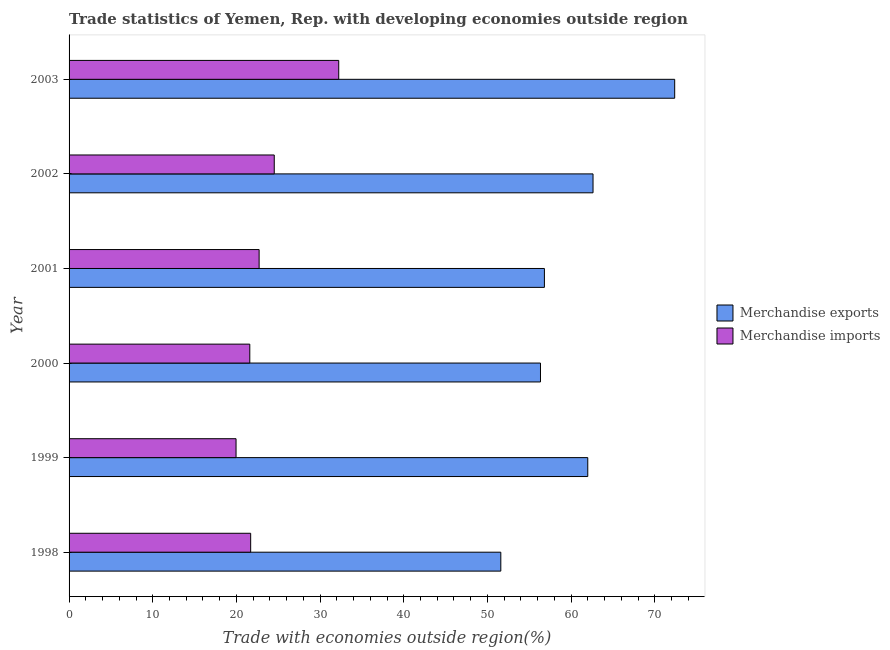How many groups of bars are there?
Provide a short and direct response. 6. How many bars are there on the 3rd tick from the top?
Your response must be concise. 2. How many bars are there on the 2nd tick from the bottom?
Provide a short and direct response. 2. What is the label of the 1st group of bars from the top?
Your answer should be very brief. 2003. What is the merchandise exports in 1999?
Your answer should be very brief. 61.99. Across all years, what is the maximum merchandise imports?
Your response must be concise. 32.23. Across all years, what is the minimum merchandise exports?
Offer a terse response. 51.6. What is the total merchandise imports in the graph?
Make the answer very short. 142.72. What is the difference between the merchandise imports in 2002 and that in 2003?
Provide a succinct answer. -7.71. What is the difference between the merchandise exports in 1998 and the merchandise imports in 2000?
Keep it short and to the point. 30. What is the average merchandise exports per year?
Your response must be concise. 60.29. In the year 1998, what is the difference between the merchandise exports and merchandise imports?
Ensure brevity in your answer.  29.9. What is the ratio of the merchandise imports in 1999 to that in 2000?
Keep it short and to the point. 0.92. Is the difference between the merchandise imports in 1999 and 2002 greater than the difference between the merchandise exports in 1999 and 2002?
Your answer should be compact. No. What is the difference between the highest and the second highest merchandise imports?
Offer a terse response. 7.71. What is the difference between the highest and the lowest merchandise exports?
Make the answer very short. 20.78. What does the 2nd bar from the top in 2002 represents?
Offer a very short reply. Merchandise exports. What does the 2nd bar from the bottom in 1998 represents?
Provide a succinct answer. Merchandise imports. How many years are there in the graph?
Make the answer very short. 6. What is the difference between two consecutive major ticks on the X-axis?
Provide a short and direct response. 10. Does the graph contain grids?
Keep it short and to the point. No. How many legend labels are there?
Make the answer very short. 2. What is the title of the graph?
Make the answer very short. Trade statistics of Yemen, Rep. with developing economies outside region. What is the label or title of the X-axis?
Your answer should be compact. Trade with economies outside region(%). What is the label or title of the Y-axis?
Provide a succinct answer. Year. What is the Trade with economies outside region(%) of Merchandise exports in 1998?
Offer a terse response. 51.6. What is the Trade with economies outside region(%) in Merchandise imports in 1998?
Offer a terse response. 21.7. What is the Trade with economies outside region(%) in Merchandise exports in 1999?
Your answer should be very brief. 61.99. What is the Trade with economies outside region(%) in Merchandise imports in 1999?
Keep it short and to the point. 19.96. What is the Trade with economies outside region(%) of Merchandise exports in 2000?
Give a very brief answer. 56.34. What is the Trade with economies outside region(%) of Merchandise imports in 2000?
Give a very brief answer. 21.6. What is the Trade with economies outside region(%) of Merchandise exports in 2001?
Provide a short and direct response. 56.81. What is the Trade with economies outside region(%) in Merchandise imports in 2001?
Your answer should be compact. 22.71. What is the Trade with economies outside region(%) in Merchandise exports in 2002?
Keep it short and to the point. 62.62. What is the Trade with economies outside region(%) in Merchandise imports in 2002?
Your answer should be compact. 24.52. What is the Trade with economies outside region(%) in Merchandise exports in 2003?
Your answer should be very brief. 72.38. What is the Trade with economies outside region(%) in Merchandise imports in 2003?
Offer a terse response. 32.23. Across all years, what is the maximum Trade with economies outside region(%) in Merchandise exports?
Provide a succinct answer. 72.38. Across all years, what is the maximum Trade with economies outside region(%) of Merchandise imports?
Your answer should be compact. 32.23. Across all years, what is the minimum Trade with economies outside region(%) of Merchandise exports?
Provide a succinct answer. 51.6. Across all years, what is the minimum Trade with economies outside region(%) of Merchandise imports?
Provide a short and direct response. 19.96. What is the total Trade with economies outside region(%) of Merchandise exports in the graph?
Ensure brevity in your answer.  361.74. What is the total Trade with economies outside region(%) of Merchandise imports in the graph?
Provide a short and direct response. 142.72. What is the difference between the Trade with economies outside region(%) in Merchandise exports in 1998 and that in 1999?
Make the answer very short. -10.39. What is the difference between the Trade with economies outside region(%) in Merchandise imports in 1998 and that in 1999?
Make the answer very short. 1.75. What is the difference between the Trade with economies outside region(%) in Merchandise exports in 1998 and that in 2000?
Offer a very short reply. -4.74. What is the difference between the Trade with economies outside region(%) in Merchandise imports in 1998 and that in 2000?
Offer a terse response. 0.1. What is the difference between the Trade with economies outside region(%) of Merchandise exports in 1998 and that in 2001?
Give a very brief answer. -5.21. What is the difference between the Trade with economies outside region(%) of Merchandise imports in 1998 and that in 2001?
Ensure brevity in your answer.  -1.01. What is the difference between the Trade with economies outside region(%) of Merchandise exports in 1998 and that in 2002?
Your answer should be compact. -11.02. What is the difference between the Trade with economies outside region(%) of Merchandise imports in 1998 and that in 2002?
Provide a short and direct response. -2.82. What is the difference between the Trade with economies outside region(%) of Merchandise exports in 1998 and that in 2003?
Your answer should be compact. -20.78. What is the difference between the Trade with economies outside region(%) in Merchandise imports in 1998 and that in 2003?
Give a very brief answer. -10.53. What is the difference between the Trade with economies outside region(%) of Merchandise exports in 1999 and that in 2000?
Offer a terse response. 5.65. What is the difference between the Trade with economies outside region(%) in Merchandise imports in 1999 and that in 2000?
Your answer should be very brief. -1.64. What is the difference between the Trade with economies outside region(%) in Merchandise exports in 1999 and that in 2001?
Keep it short and to the point. 5.18. What is the difference between the Trade with economies outside region(%) of Merchandise imports in 1999 and that in 2001?
Your response must be concise. -2.76. What is the difference between the Trade with economies outside region(%) of Merchandise exports in 1999 and that in 2002?
Your response must be concise. -0.63. What is the difference between the Trade with economies outside region(%) of Merchandise imports in 1999 and that in 2002?
Your answer should be very brief. -4.57. What is the difference between the Trade with economies outside region(%) of Merchandise exports in 1999 and that in 2003?
Make the answer very short. -10.39. What is the difference between the Trade with economies outside region(%) in Merchandise imports in 1999 and that in 2003?
Ensure brevity in your answer.  -12.27. What is the difference between the Trade with economies outside region(%) in Merchandise exports in 2000 and that in 2001?
Your response must be concise. -0.47. What is the difference between the Trade with economies outside region(%) of Merchandise imports in 2000 and that in 2001?
Your answer should be very brief. -1.11. What is the difference between the Trade with economies outside region(%) of Merchandise exports in 2000 and that in 2002?
Your answer should be compact. -6.28. What is the difference between the Trade with economies outside region(%) of Merchandise imports in 2000 and that in 2002?
Keep it short and to the point. -2.92. What is the difference between the Trade with economies outside region(%) in Merchandise exports in 2000 and that in 2003?
Provide a succinct answer. -16.04. What is the difference between the Trade with economies outside region(%) of Merchandise imports in 2000 and that in 2003?
Your answer should be compact. -10.63. What is the difference between the Trade with economies outside region(%) in Merchandise exports in 2001 and that in 2002?
Your answer should be very brief. -5.81. What is the difference between the Trade with economies outside region(%) of Merchandise imports in 2001 and that in 2002?
Provide a succinct answer. -1.81. What is the difference between the Trade with economies outside region(%) of Merchandise exports in 2001 and that in 2003?
Provide a short and direct response. -15.57. What is the difference between the Trade with economies outside region(%) of Merchandise imports in 2001 and that in 2003?
Keep it short and to the point. -9.52. What is the difference between the Trade with economies outside region(%) in Merchandise exports in 2002 and that in 2003?
Provide a short and direct response. -9.76. What is the difference between the Trade with economies outside region(%) in Merchandise imports in 2002 and that in 2003?
Provide a succinct answer. -7.71. What is the difference between the Trade with economies outside region(%) of Merchandise exports in 1998 and the Trade with economies outside region(%) of Merchandise imports in 1999?
Ensure brevity in your answer.  31.64. What is the difference between the Trade with economies outside region(%) of Merchandise exports in 1998 and the Trade with economies outside region(%) of Merchandise imports in 2000?
Your answer should be very brief. 30. What is the difference between the Trade with economies outside region(%) in Merchandise exports in 1998 and the Trade with economies outside region(%) in Merchandise imports in 2001?
Make the answer very short. 28.89. What is the difference between the Trade with economies outside region(%) of Merchandise exports in 1998 and the Trade with economies outside region(%) of Merchandise imports in 2002?
Make the answer very short. 27.08. What is the difference between the Trade with economies outside region(%) of Merchandise exports in 1998 and the Trade with economies outside region(%) of Merchandise imports in 2003?
Your answer should be compact. 19.37. What is the difference between the Trade with economies outside region(%) in Merchandise exports in 1999 and the Trade with economies outside region(%) in Merchandise imports in 2000?
Provide a succinct answer. 40.39. What is the difference between the Trade with economies outside region(%) in Merchandise exports in 1999 and the Trade with economies outside region(%) in Merchandise imports in 2001?
Offer a terse response. 39.28. What is the difference between the Trade with economies outside region(%) in Merchandise exports in 1999 and the Trade with economies outside region(%) in Merchandise imports in 2002?
Give a very brief answer. 37.47. What is the difference between the Trade with economies outside region(%) in Merchandise exports in 1999 and the Trade with economies outside region(%) in Merchandise imports in 2003?
Provide a short and direct response. 29.76. What is the difference between the Trade with economies outside region(%) of Merchandise exports in 2000 and the Trade with economies outside region(%) of Merchandise imports in 2001?
Ensure brevity in your answer.  33.63. What is the difference between the Trade with economies outside region(%) of Merchandise exports in 2000 and the Trade with economies outside region(%) of Merchandise imports in 2002?
Provide a short and direct response. 31.82. What is the difference between the Trade with economies outside region(%) in Merchandise exports in 2000 and the Trade with economies outside region(%) in Merchandise imports in 2003?
Provide a succinct answer. 24.11. What is the difference between the Trade with economies outside region(%) of Merchandise exports in 2001 and the Trade with economies outside region(%) of Merchandise imports in 2002?
Give a very brief answer. 32.29. What is the difference between the Trade with economies outside region(%) in Merchandise exports in 2001 and the Trade with economies outside region(%) in Merchandise imports in 2003?
Give a very brief answer. 24.58. What is the difference between the Trade with economies outside region(%) in Merchandise exports in 2002 and the Trade with economies outside region(%) in Merchandise imports in 2003?
Keep it short and to the point. 30.39. What is the average Trade with economies outside region(%) in Merchandise exports per year?
Provide a short and direct response. 60.29. What is the average Trade with economies outside region(%) in Merchandise imports per year?
Your response must be concise. 23.79. In the year 1998, what is the difference between the Trade with economies outside region(%) of Merchandise exports and Trade with economies outside region(%) of Merchandise imports?
Provide a short and direct response. 29.9. In the year 1999, what is the difference between the Trade with economies outside region(%) of Merchandise exports and Trade with economies outside region(%) of Merchandise imports?
Offer a terse response. 42.04. In the year 2000, what is the difference between the Trade with economies outside region(%) in Merchandise exports and Trade with economies outside region(%) in Merchandise imports?
Your answer should be very brief. 34.74. In the year 2001, what is the difference between the Trade with economies outside region(%) of Merchandise exports and Trade with economies outside region(%) of Merchandise imports?
Your response must be concise. 34.1. In the year 2002, what is the difference between the Trade with economies outside region(%) of Merchandise exports and Trade with economies outside region(%) of Merchandise imports?
Offer a very short reply. 38.1. In the year 2003, what is the difference between the Trade with economies outside region(%) of Merchandise exports and Trade with economies outside region(%) of Merchandise imports?
Keep it short and to the point. 40.15. What is the ratio of the Trade with economies outside region(%) of Merchandise exports in 1998 to that in 1999?
Offer a very short reply. 0.83. What is the ratio of the Trade with economies outside region(%) in Merchandise imports in 1998 to that in 1999?
Offer a terse response. 1.09. What is the ratio of the Trade with economies outside region(%) in Merchandise exports in 1998 to that in 2000?
Ensure brevity in your answer.  0.92. What is the ratio of the Trade with economies outside region(%) of Merchandise imports in 1998 to that in 2000?
Offer a terse response. 1. What is the ratio of the Trade with economies outside region(%) in Merchandise exports in 1998 to that in 2001?
Provide a succinct answer. 0.91. What is the ratio of the Trade with economies outside region(%) in Merchandise imports in 1998 to that in 2001?
Provide a short and direct response. 0.96. What is the ratio of the Trade with economies outside region(%) in Merchandise exports in 1998 to that in 2002?
Provide a succinct answer. 0.82. What is the ratio of the Trade with economies outside region(%) in Merchandise imports in 1998 to that in 2002?
Provide a short and direct response. 0.89. What is the ratio of the Trade with economies outside region(%) of Merchandise exports in 1998 to that in 2003?
Provide a succinct answer. 0.71. What is the ratio of the Trade with economies outside region(%) in Merchandise imports in 1998 to that in 2003?
Your answer should be compact. 0.67. What is the ratio of the Trade with economies outside region(%) in Merchandise exports in 1999 to that in 2000?
Your answer should be compact. 1.1. What is the ratio of the Trade with economies outside region(%) in Merchandise imports in 1999 to that in 2000?
Give a very brief answer. 0.92. What is the ratio of the Trade with economies outside region(%) of Merchandise exports in 1999 to that in 2001?
Ensure brevity in your answer.  1.09. What is the ratio of the Trade with economies outside region(%) of Merchandise imports in 1999 to that in 2001?
Give a very brief answer. 0.88. What is the ratio of the Trade with economies outside region(%) in Merchandise imports in 1999 to that in 2002?
Your response must be concise. 0.81. What is the ratio of the Trade with economies outside region(%) in Merchandise exports in 1999 to that in 2003?
Ensure brevity in your answer.  0.86. What is the ratio of the Trade with economies outside region(%) of Merchandise imports in 1999 to that in 2003?
Offer a very short reply. 0.62. What is the ratio of the Trade with economies outside region(%) of Merchandise imports in 2000 to that in 2001?
Your response must be concise. 0.95. What is the ratio of the Trade with economies outside region(%) in Merchandise exports in 2000 to that in 2002?
Provide a short and direct response. 0.9. What is the ratio of the Trade with economies outside region(%) in Merchandise imports in 2000 to that in 2002?
Provide a short and direct response. 0.88. What is the ratio of the Trade with economies outside region(%) in Merchandise exports in 2000 to that in 2003?
Your answer should be very brief. 0.78. What is the ratio of the Trade with economies outside region(%) of Merchandise imports in 2000 to that in 2003?
Your answer should be compact. 0.67. What is the ratio of the Trade with economies outside region(%) of Merchandise exports in 2001 to that in 2002?
Your response must be concise. 0.91. What is the ratio of the Trade with economies outside region(%) of Merchandise imports in 2001 to that in 2002?
Your response must be concise. 0.93. What is the ratio of the Trade with economies outside region(%) of Merchandise exports in 2001 to that in 2003?
Offer a terse response. 0.78. What is the ratio of the Trade with economies outside region(%) in Merchandise imports in 2001 to that in 2003?
Offer a very short reply. 0.7. What is the ratio of the Trade with economies outside region(%) of Merchandise exports in 2002 to that in 2003?
Ensure brevity in your answer.  0.87. What is the ratio of the Trade with economies outside region(%) of Merchandise imports in 2002 to that in 2003?
Make the answer very short. 0.76. What is the difference between the highest and the second highest Trade with economies outside region(%) of Merchandise exports?
Offer a very short reply. 9.76. What is the difference between the highest and the second highest Trade with economies outside region(%) of Merchandise imports?
Give a very brief answer. 7.71. What is the difference between the highest and the lowest Trade with economies outside region(%) in Merchandise exports?
Provide a succinct answer. 20.78. What is the difference between the highest and the lowest Trade with economies outside region(%) in Merchandise imports?
Offer a terse response. 12.27. 